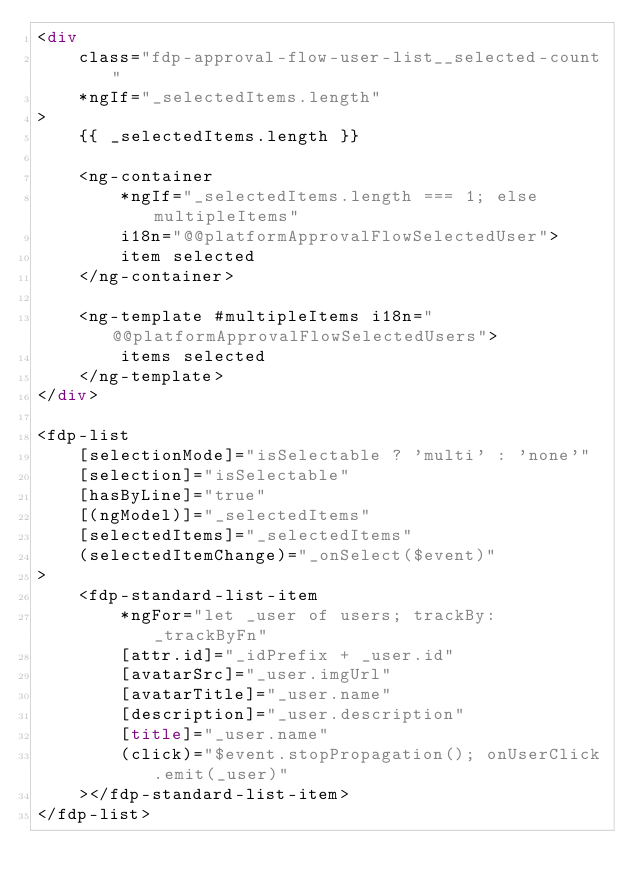Convert code to text. <code><loc_0><loc_0><loc_500><loc_500><_HTML_><div
    class="fdp-approval-flow-user-list__selected-count"
    *ngIf="_selectedItems.length"
>
    {{ _selectedItems.length }}

    <ng-container
        *ngIf="_selectedItems.length === 1; else multipleItems"
        i18n="@@platformApprovalFlowSelectedUser">
        item selected
    </ng-container>

    <ng-template #multipleItems i18n="@@platformApprovalFlowSelectedUsers">
        items selected
    </ng-template>
</div>

<fdp-list
    [selectionMode]="isSelectable ? 'multi' : 'none'"
    [selection]="isSelectable"
    [hasByLine]="true"
    [(ngModel)]="_selectedItems"
    [selectedItems]="_selectedItems"
    (selectedItemChange)="_onSelect($event)"
>
    <fdp-standard-list-item
        *ngFor="let _user of users; trackBy: _trackByFn"
        [attr.id]="_idPrefix + _user.id"
        [avatarSrc]="_user.imgUrl"
        [avatarTitle]="_user.name"
        [description]="_user.description"
        [title]="_user.name"
        (click)="$event.stopPropagation(); onUserClick.emit(_user)"
    ></fdp-standard-list-item>
</fdp-list>
</code> 